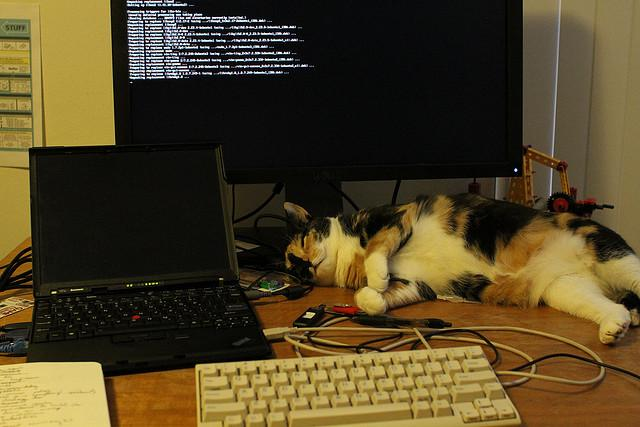How many computer screens are around the cat sleeping on the desk?

Choices:
A) two
B) three
C) five
D) four two 